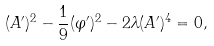Convert formula to latex. <formula><loc_0><loc_0><loc_500><loc_500>( A ^ { \prime } ) ^ { 2 } - \frac { 1 } { 9 } ( \varphi ^ { \prime } ) ^ { 2 } - 2 \lambda ( A ^ { \prime } ) ^ { 4 } = 0 ,</formula> 